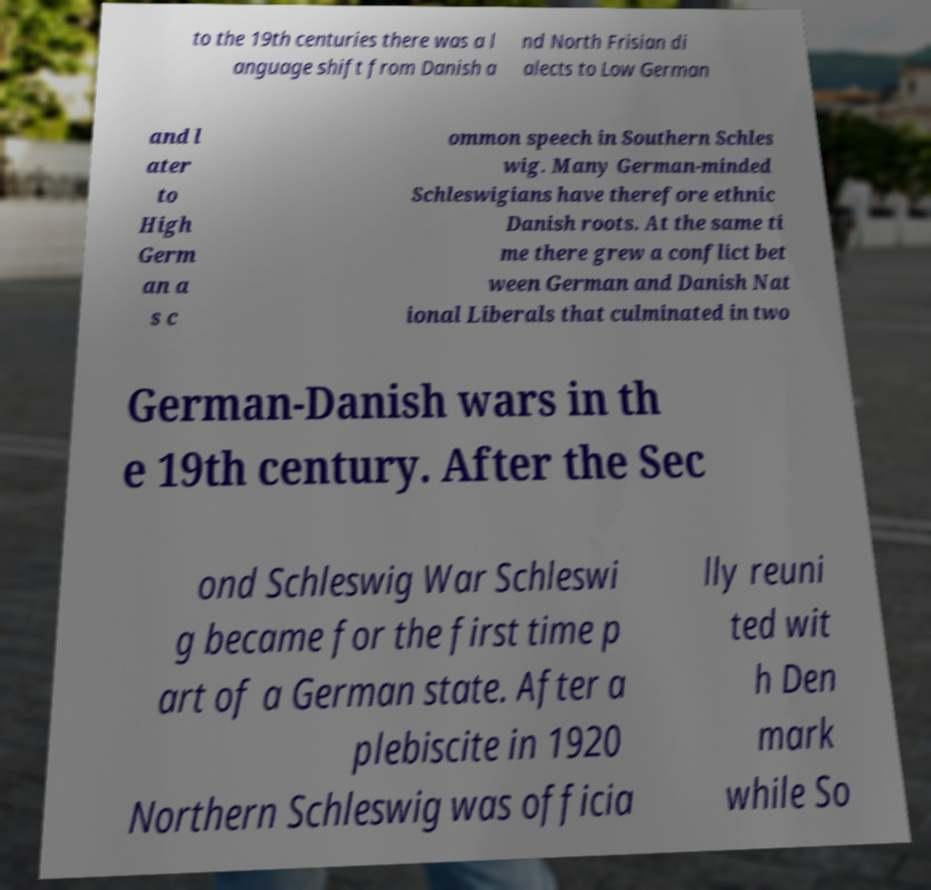Could you assist in decoding the text presented in this image and type it out clearly? to the 19th centuries there was a l anguage shift from Danish a nd North Frisian di alects to Low German and l ater to High Germ an a s c ommon speech in Southern Schles wig. Many German-minded Schleswigians have therefore ethnic Danish roots. At the same ti me there grew a conflict bet ween German and Danish Nat ional Liberals that culminated in two German-Danish wars in th e 19th century. After the Sec ond Schleswig War Schleswi g became for the first time p art of a German state. After a plebiscite in 1920 Northern Schleswig was officia lly reuni ted wit h Den mark while So 